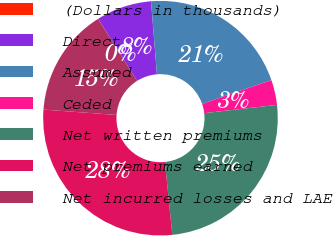<chart> <loc_0><loc_0><loc_500><loc_500><pie_chart><fcel>(Dollars in thousands)<fcel>Direct<fcel>Assumed<fcel>Ceded<fcel>Net written premiums<fcel>Net premiums earned<fcel>Net incurred losses and LAE<nl><fcel>0.01%<fcel>7.63%<fcel>21.02%<fcel>3.45%<fcel>25.2%<fcel>27.78%<fcel>14.91%<nl></chart> 